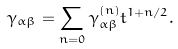<formula> <loc_0><loc_0><loc_500><loc_500>\gamma _ { \alpha \beta } = \sum _ { n = 0 } \gamma _ { \alpha \beta } ^ { ( n ) } t ^ { 1 + n / 2 } .</formula> 